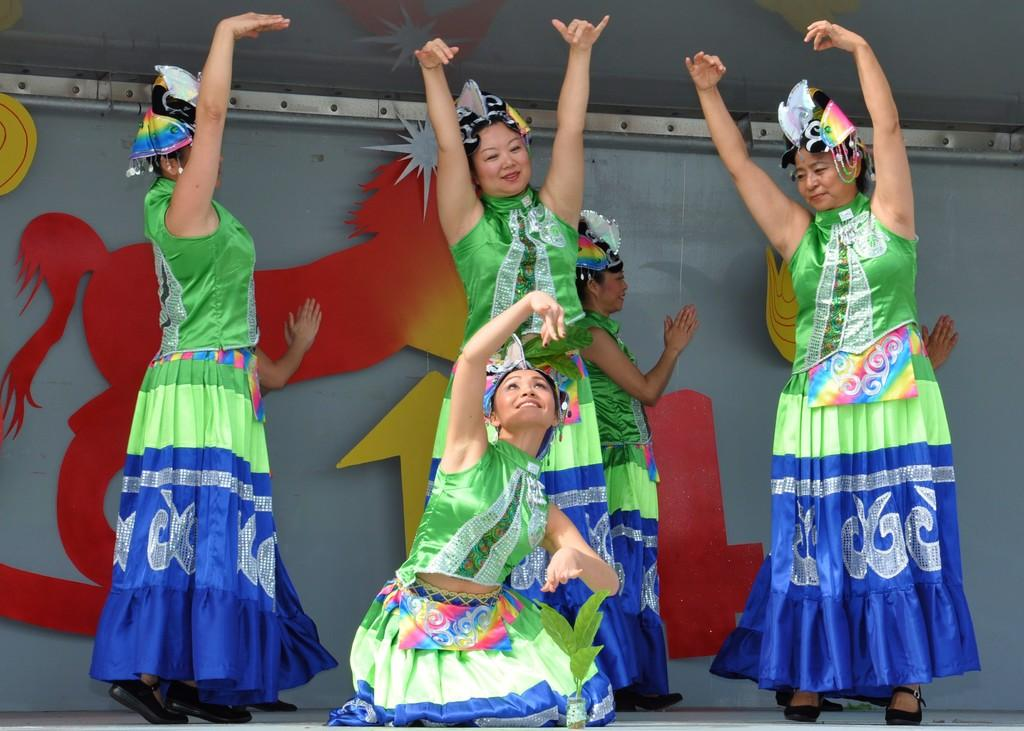How many people are in the image? There are persons in the image, but the exact number is not specified. What are the persons wearing? The persons are wearing clothes. What activity are the persons engaged in? The persons are acting in a play. What can be seen in the background of the image? There is a wall in the background of the image. Is there a source of water visible in the image? There is no mention of water or any related activity in the image. Can you see an iron in the image? There is no iron present in the image. 